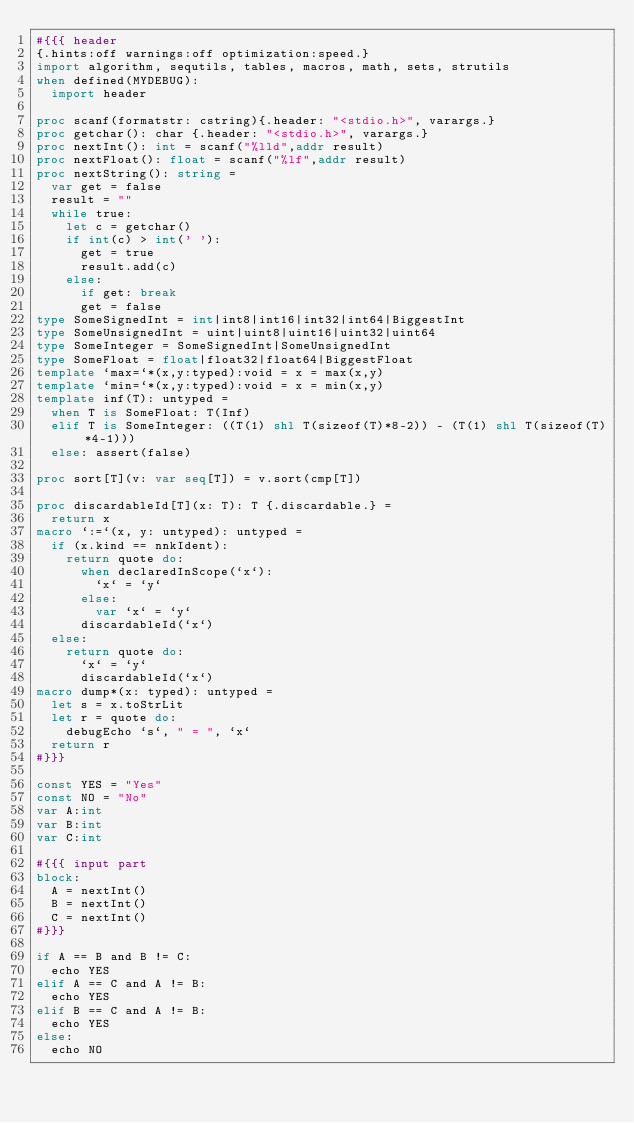<code> <loc_0><loc_0><loc_500><loc_500><_Nim_>#{{{ header
{.hints:off warnings:off optimization:speed.}
import algorithm, sequtils, tables, macros, math, sets, strutils
when defined(MYDEBUG):
  import header

proc scanf(formatstr: cstring){.header: "<stdio.h>", varargs.}
proc getchar(): char {.header: "<stdio.h>", varargs.}
proc nextInt(): int = scanf("%lld",addr result)
proc nextFloat(): float = scanf("%lf",addr result)
proc nextString(): string =
  var get = false
  result = ""
  while true:
    let c = getchar()
    if int(c) > int(' '):
      get = true
      result.add(c)
    else:
      if get: break
      get = false
type SomeSignedInt = int|int8|int16|int32|int64|BiggestInt
type SomeUnsignedInt = uint|uint8|uint16|uint32|uint64
type SomeInteger = SomeSignedInt|SomeUnsignedInt
type SomeFloat = float|float32|float64|BiggestFloat
template `max=`*(x,y:typed):void = x = max(x,y)
template `min=`*(x,y:typed):void = x = min(x,y)
template inf(T): untyped = 
  when T is SomeFloat: T(Inf)
  elif T is SomeInteger: ((T(1) shl T(sizeof(T)*8-2)) - (T(1) shl T(sizeof(T)*4-1)))
  else: assert(false)

proc sort[T](v: var seq[T]) = v.sort(cmp[T])

proc discardableId[T](x: T): T {.discardable.} =
  return x
macro `:=`(x, y: untyped): untyped =
  if (x.kind == nnkIdent):
    return quote do:
      when declaredInScope(`x`):
        `x` = `y`
      else:
        var `x` = `y`
      discardableId(`x`)
  else:
    return quote do:
      `x` = `y`
      discardableId(`x`)
macro dump*(x: typed): untyped =
  let s = x.toStrLit
  let r = quote do:
    debugEcho `s`, " = ", `x`
  return r
#}}}

const YES = "Yes"
const NO = "No"
var A:int
var B:int
var C:int

#{{{ input part
block:
  A = nextInt()
  B = nextInt()
  C = nextInt()
#}}}

if A == B and B != C:
  echo YES
elif A == C and A != B:
  echo YES
elif B == C and A != B:
  echo YES
else:
  echo NO

</code> 